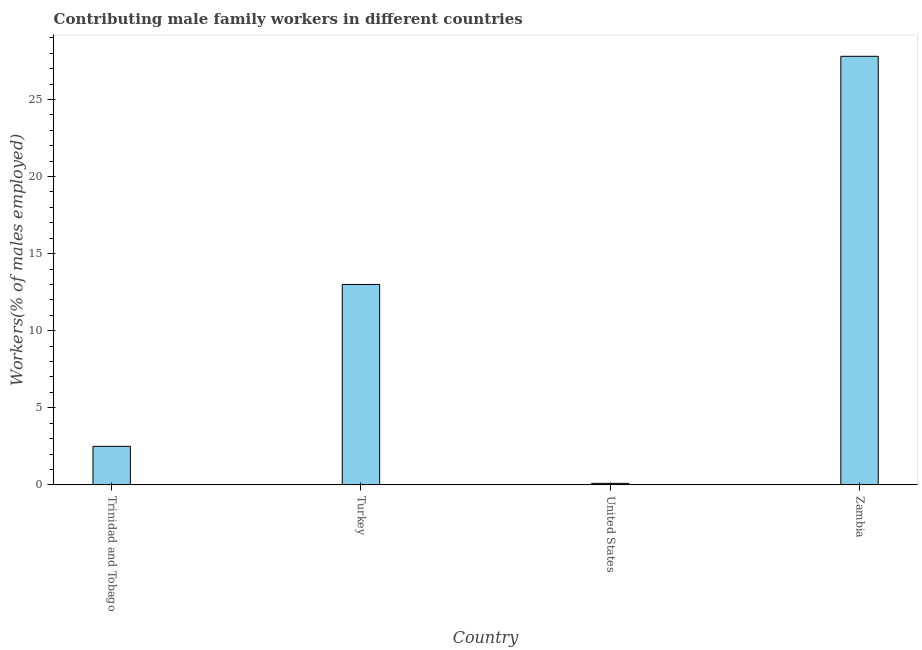Does the graph contain any zero values?
Keep it short and to the point. No. What is the title of the graph?
Your answer should be very brief. Contributing male family workers in different countries. What is the label or title of the Y-axis?
Keep it short and to the point. Workers(% of males employed). What is the contributing male family workers in Trinidad and Tobago?
Keep it short and to the point. 2.5. Across all countries, what is the maximum contributing male family workers?
Your answer should be compact. 27.8. Across all countries, what is the minimum contributing male family workers?
Your response must be concise. 0.1. In which country was the contributing male family workers maximum?
Provide a short and direct response. Zambia. In which country was the contributing male family workers minimum?
Keep it short and to the point. United States. What is the sum of the contributing male family workers?
Your answer should be compact. 43.4. What is the difference between the contributing male family workers in Turkey and United States?
Make the answer very short. 12.9. What is the average contributing male family workers per country?
Give a very brief answer. 10.85. What is the median contributing male family workers?
Provide a succinct answer. 7.75. What is the ratio of the contributing male family workers in Turkey to that in Zambia?
Offer a terse response. 0.47. What is the difference between the highest and the lowest contributing male family workers?
Keep it short and to the point. 27.7. How many bars are there?
Your response must be concise. 4. How many countries are there in the graph?
Keep it short and to the point. 4. What is the Workers(% of males employed) in Trinidad and Tobago?
Provide a short and direct response. 2.5. What is the Workers(% of males employed) of United States?
Provide a short and direct response. 0.1. What is the Workers(% of males employed) in Zambia?
Make the answer very short. 27.8. What is the difference between the Workers(% of males employed) in Trinidad and Tobago and Turkey?
Keep it short and to the point. -10.5. What is the difference between the Workers(% of males employed) in Trinidad and Tobago and Zambia?
Ensure brevity in your answer.  -25.3. What is the difference between the Workers(% of males employed) in Turkey and Zambia?
Offer a very short reply. -14.8. What is the difference between the Workers(% of males employed) in United States and Zambia?
Your response must be concise. -27.7. What is the ratio of the Workers(% of males employed) in Trinidad and Tobago to that in Turkey?
Offer a terse response. 0.19. What is the ratio of the Workers(% of males employed) in Trinidad and Tobago to that in United States?
Provide a short and direct response. 25. What is the ratio of the Workers(% of males employed) in Trinidad and Tobago to that in Zambia?
Your response must be concise. 0.09. What is the ratio of the Workers(% of males employed) in Turkey to that in United States?
Make the answer very short. 130. What is the ratio of the Workers(% of males employed) in Turkey to that in Zambia?
Keep it short and to the point. 0.47. What is the ratio of the Workers(% of males employed) in United States to that in Zambia?
Your answer should be compact. 0. 